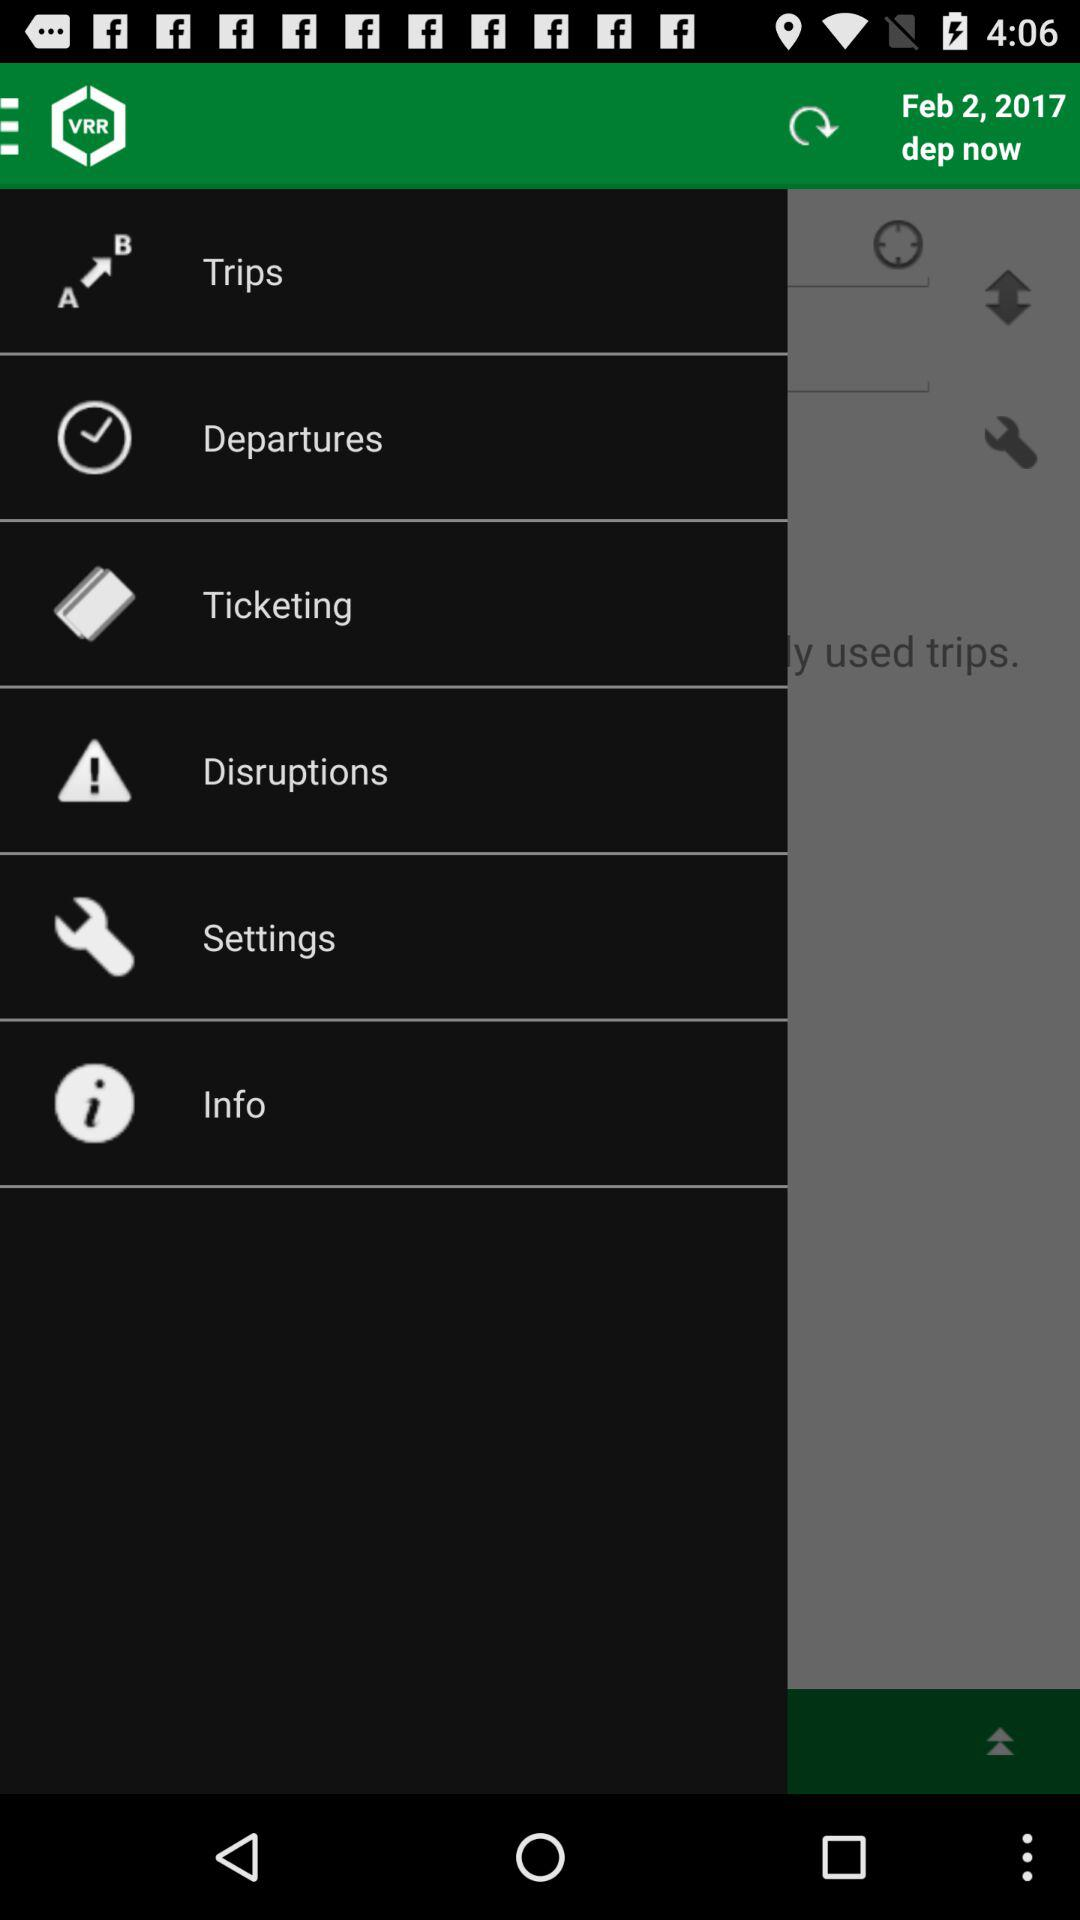What is the date? The date is 2 February, 2017. 